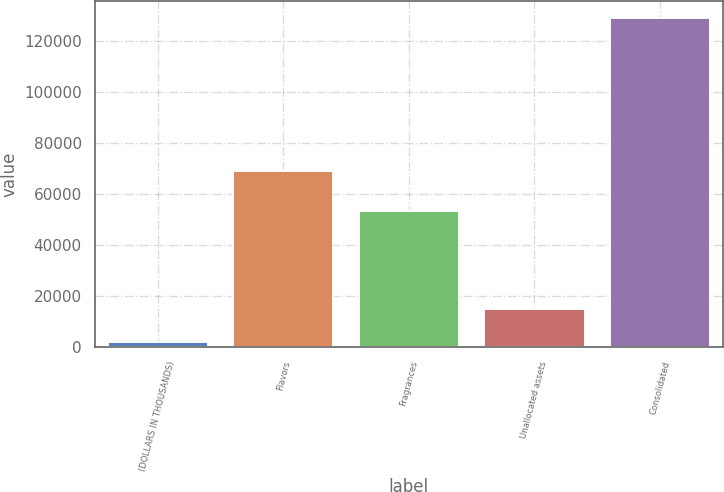Convert chart to OTSL. <chart><loc_0><loc_0><loc_500><loc_500><bar_chart><fcel>(DOLLARS IN THOUSANDS)<fcel>Flavors<fcel>Fragrances<fcel>Unallocated assets<fcel>Consolidated<nl><fcel>2017<fcel>68937<fcel>53089<fcel>14712.6<fcel>128973<nl></chart> 